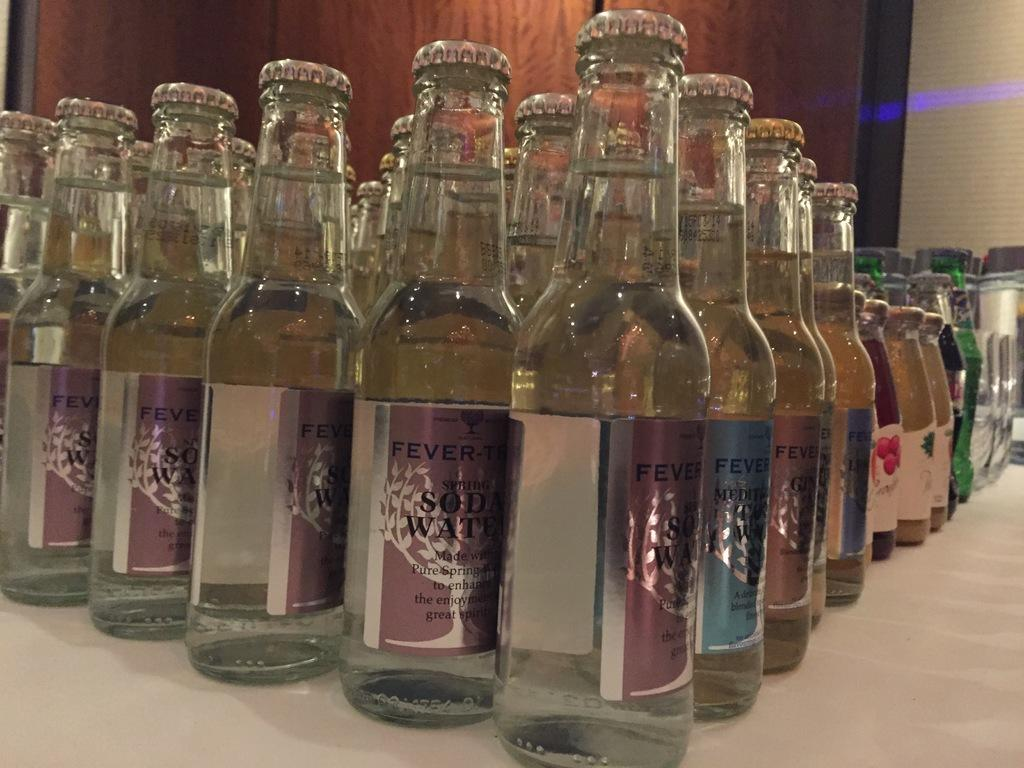<image>
Render a clear and concise summary of the photo. Several bottles of soda water sit on a table. 